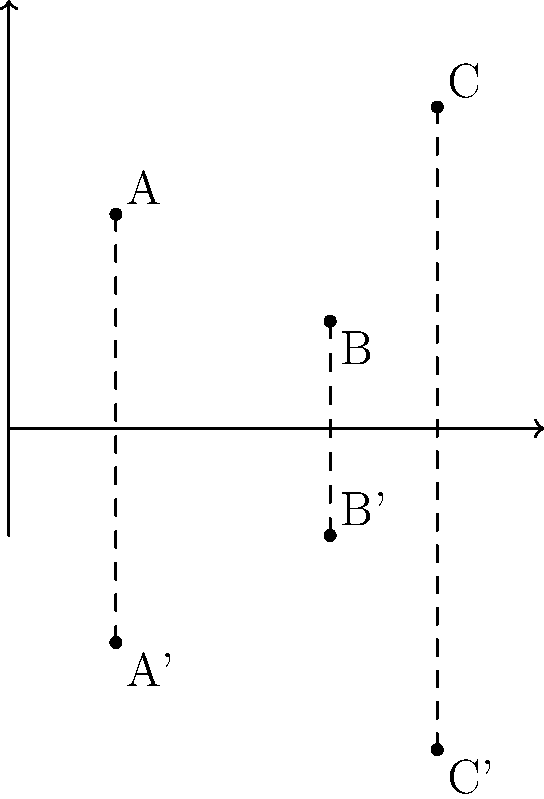Given three points A(1,2), B(3,1), and C(4,3) in a Cartesian plane, reflect these points across the x-axis. Write a function in pseudocode that takes the coordinates of a point (x,y) as input and returns the coordinates of the reflected point. Then, use this function to determine the coordinates of A', B', and C'. To solve this problem, we'll follow these steps:

1. Understand the reflection across the x-axis:
   When a point is reflected across the x-axis, its x-coordinate remains the same, but its y-coordinate changes sign.

2. Write a function in pseudocode:
   ```
   function reflect_across_x_axis(x, y):
       return (x, -y)
   ```

3. Apply the function to each point:

   For A(1,2):
   A' = reflect_across_x_axis(1, 2) = (1, -2)

   For B(3,1):
   B' = reflect_across_x_axis(3, 1) = (3, -1)

   For C(4,3):
   C' = reflect_across_x_axis(4, 3) = (4, -3)

4. Verify the results:
   The reflected points A', B', and C' should have the same x-coordinates as A, B, and C respectively, but with negated y-coordinates.

This approach demonstrates the use of a function to encapsulate the reflection logic, which is an efficient programming practice. It also shows how to apply the same operation (reflection) to multiple data points, which is a common task in transformational geometry and computer graphics.
Answer: A'(1,-2), B'(3,-1), C'(4,-3) 